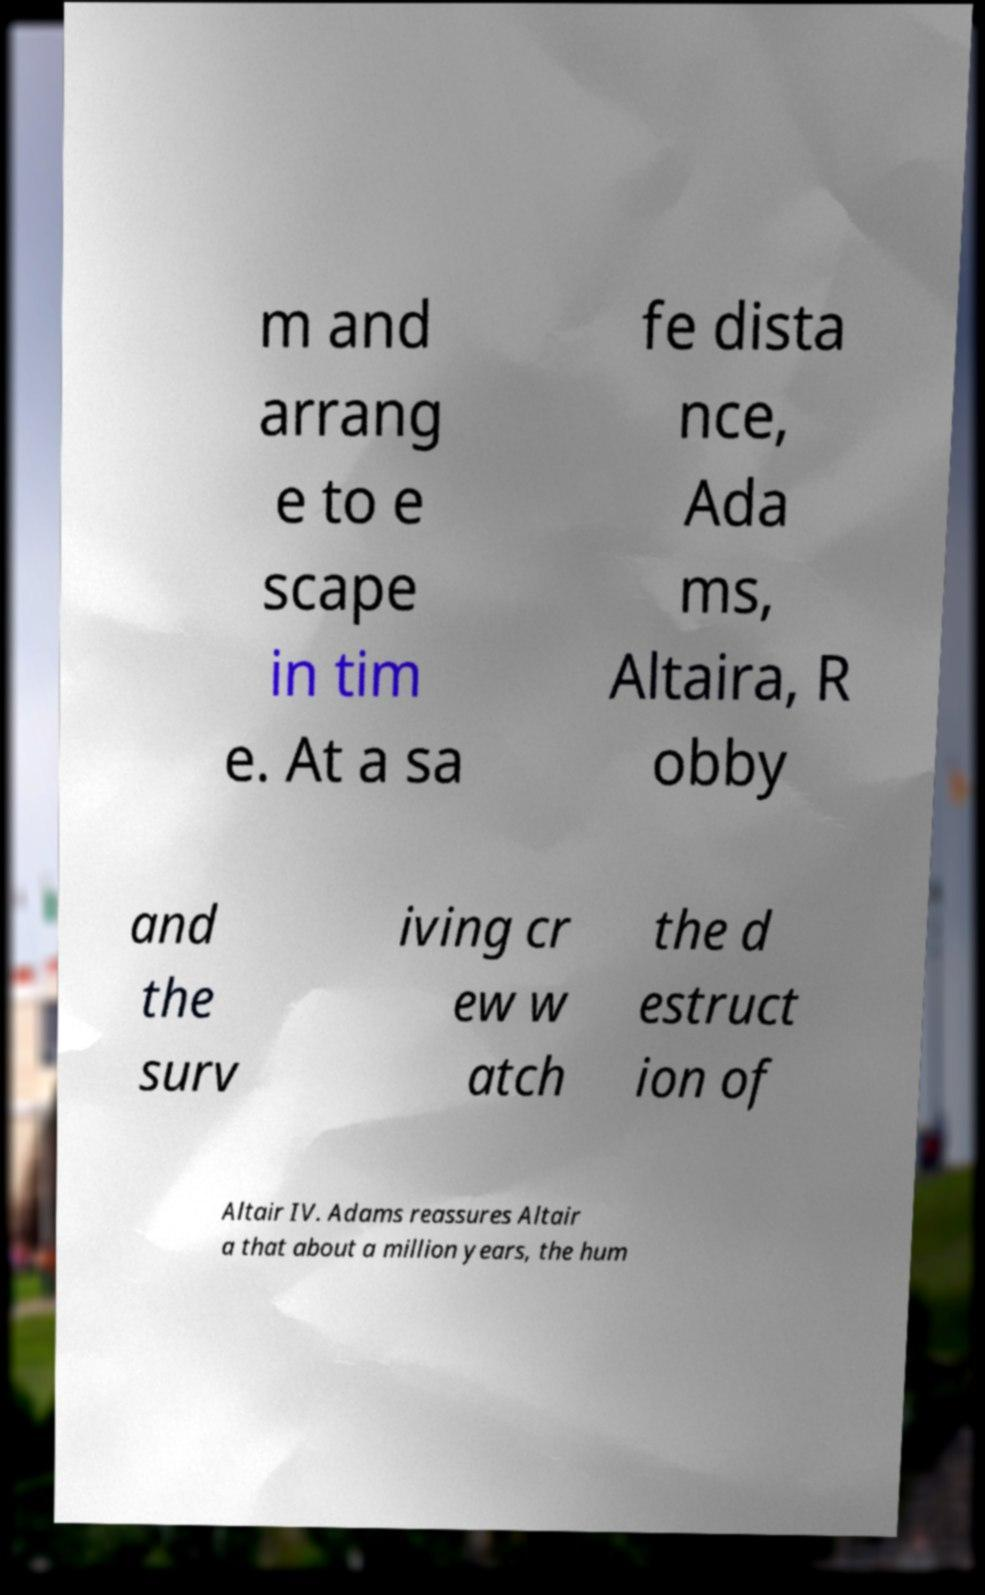Please read and relay the text visible in this image. What does it say? m and arrang e to e scape in tim e. At a sa fe dista nce, Ada ms, Altaira, R obby and the surv iving cr ew w atch the d estruct ion of Altair IV. Adams reassures Altair a that about a million years, the hum 